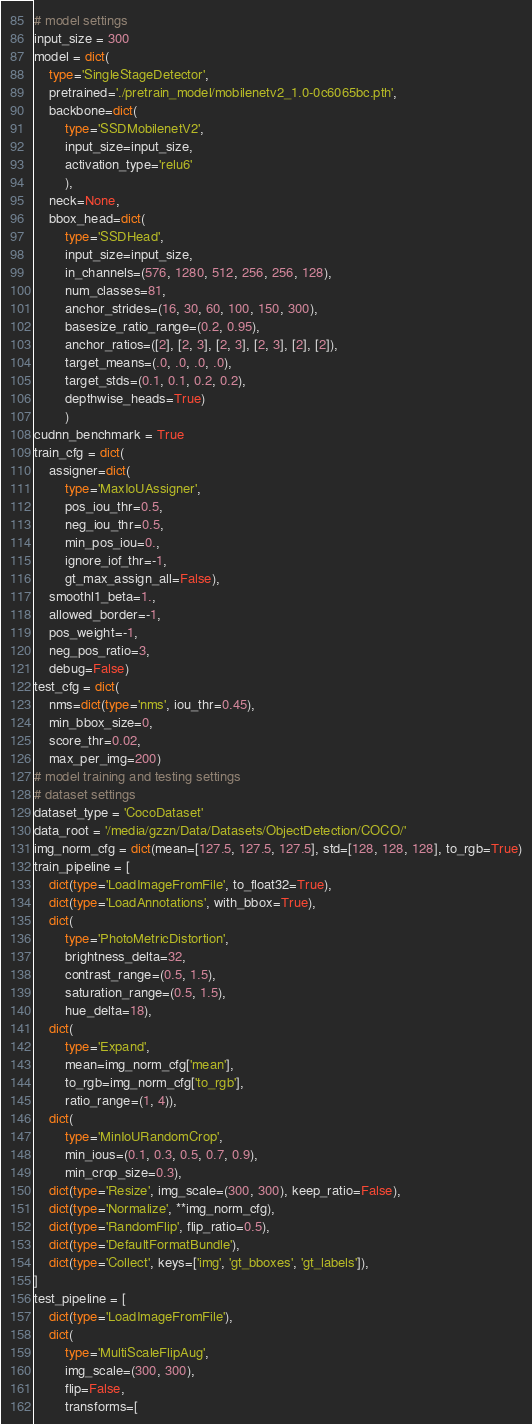Convert code to text. <code><loc_0><loc_0><loc_500><loc_500><_Python_># model settings
input_size = 300
model = dict(
    type='SingleStageDetector',
    pretrained='./pretrain_model/mobilenetv2_1.0-0c6065bc.pth',
    backbone=dict(
        type='SSDMobilenetV2',
        input_size=input_size,
        activation_type='relu6'
        ),
    neck=None,
    bbox_head=dict(
        type='SSDHead',
        input_size=input_size,
        in_channels=(576, 1280, 512, 256, 256, 128),
        num_classes=81,
        anchor_strides=(16, 30, 60, 100, 150, 300),
        basesize_ratio_range=(0.2, 0.95),
        anchor_ratios=([2], [2, 3], [2, 3], [2, 3], [2], [2]),
        target_means=(.0, .0, .0, .0),
        target_stds=(0.1, 0.1, 0.2, 0.2),
        depthwise_heads=True)
        )
cudnn_benchmark = True
train_cfg = dict(
    assigner=dict(
        type='MaxIoUAssigner',
        pos_iou_thr=0.5,
        neg_iou_thr=0.5,
        min_pos_iou=0.,
        ignore_iof_thr=-1,
        gt_max_assign_all=False),
    smoothl1_beta=1.,
    allowed_border=-1,
    pos_weight=-1,
    neg_pos_ratio=3,
    debug=False)
test_cfg = dict(
    nms=dict(type='nms', iou_thr=0.45),
    min_bbox_size=0,
    score_thr=0.02,
    max_per_img=200)
# model training and testing settings
# dataset settings
dataset_type = 'CocoDataset'
data_root = '/media/gzzn/Data/Datasets/ObjectDetection/COCO/'
img_norm_cfg = dict(mean=[127.5, 127.5, 127.5], std=[128, 128, 128], to_rgb=True)
train_pipeline = [
    dict(type='LoadImageFromFile', to_float32=True),
    dict(type='LoadAnnotations', with_bbox=True),
    dict(
        type='PhotoMetricDistortion',
        brightness_delta=32,
        contrast_range=(0.5, 1.5),
        saturation_range=(0.5, 1.5),
        hue_delta=18),
    dict(
        type='Expand',
        mean=img_norm_cfg['mean'],
        to_rgb=img_norm_cfg['to_rgb'],
        ratio_range=(1, 4)),
    dict(
        type='MinIoURandomCrop',
        min_ious=(0.1, 0.3, 0.5, 0.7, 0.9),
        min_crop_size=0.3),
    dict(type='Resize', img_scale=(300, 300), keep_ratio=False),
    dict(type='Normalize', **img_norm_cfg),
    dict(type='RandomFlip', flip_ratio=0.5),
    dict(type='DefaultFormatBundle'),
    dict(type='Collect', keys=['img', 'gt_bboxes', 'gt_labels']),
]
test_pipeline = [
    dict(type='LoadImageFromFile'),
    dict(
        type='MultiScaleFlipAug',
        img_scale=(300, 300),
        flip=False,
        transforms=[</code> 